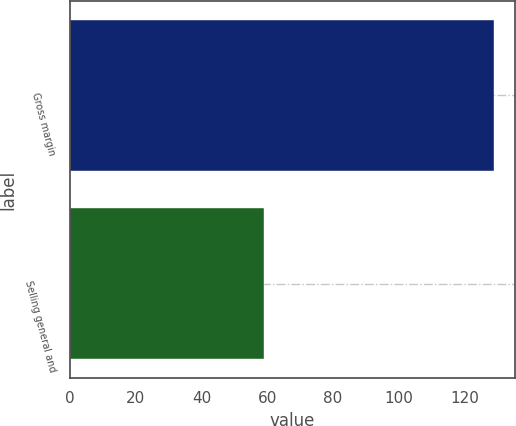Convert chart. <chart><loc_0><loc_0><loc_500><loc_500><bar_chart><fcel>Gross margin<fcel>Selling general and<nl><fcel>129<fcel>59<nl></chart> 